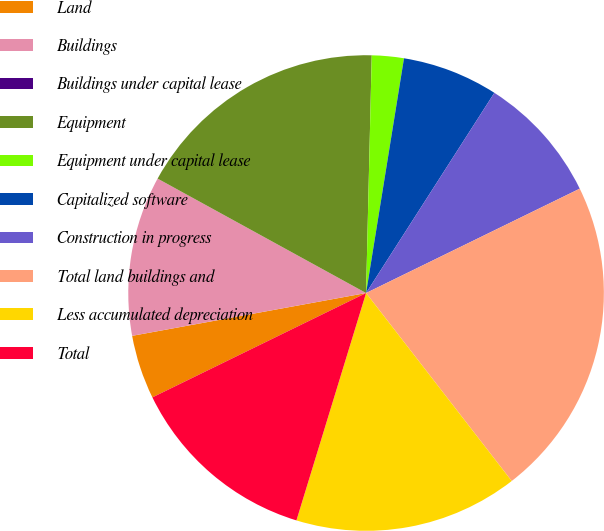Convert chart to OTSL. <chart><loc_0><loc_0><loc_500><loc_500><pie_chart><fcel>Land<fcel>Buildings<fcel>Buildings under capital lease<fcel>Equipment<fcel>Equipment under capital lease<fcel>Capitalized software<fcel>Construction in progress<fcel>Total land buildings and<fcel>Less accumulated depreciation<fcel>Total<nl><fcel>4.35%<fcel>10.87%<fcel>0.0%<fcel>17.39%<fcel>2.17%<fcel>6.52%<fcel>8.7%<fcel>21.74%<fcel>15.22%<fcel>13.04%<nl></chart> 